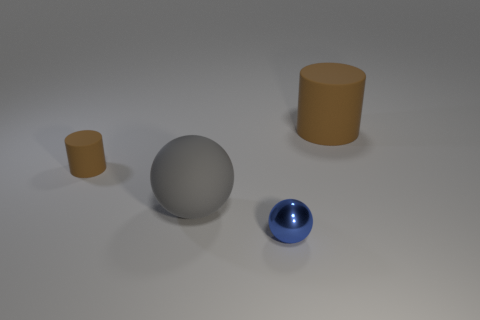Add 2 green objects. How many objects exist? 6 Subtract all gray balls. How many balls are left? 1 Subtract all blue cylinders. Subtract all red spheres. How many cylinders are left? 2 Subtract all tiny green matte cubes. Subtract all tiny things. How many objects are left? 2 Add 4 big rubber cylinders. How many big rubber cylinders are left? 5 Add 1 big brown cylinders. How many big brown cylinders exist? 2 Subtract 1 brown cylinders. How many objects are left? 3 Subtract 1 balls. How many balls are left? 1 